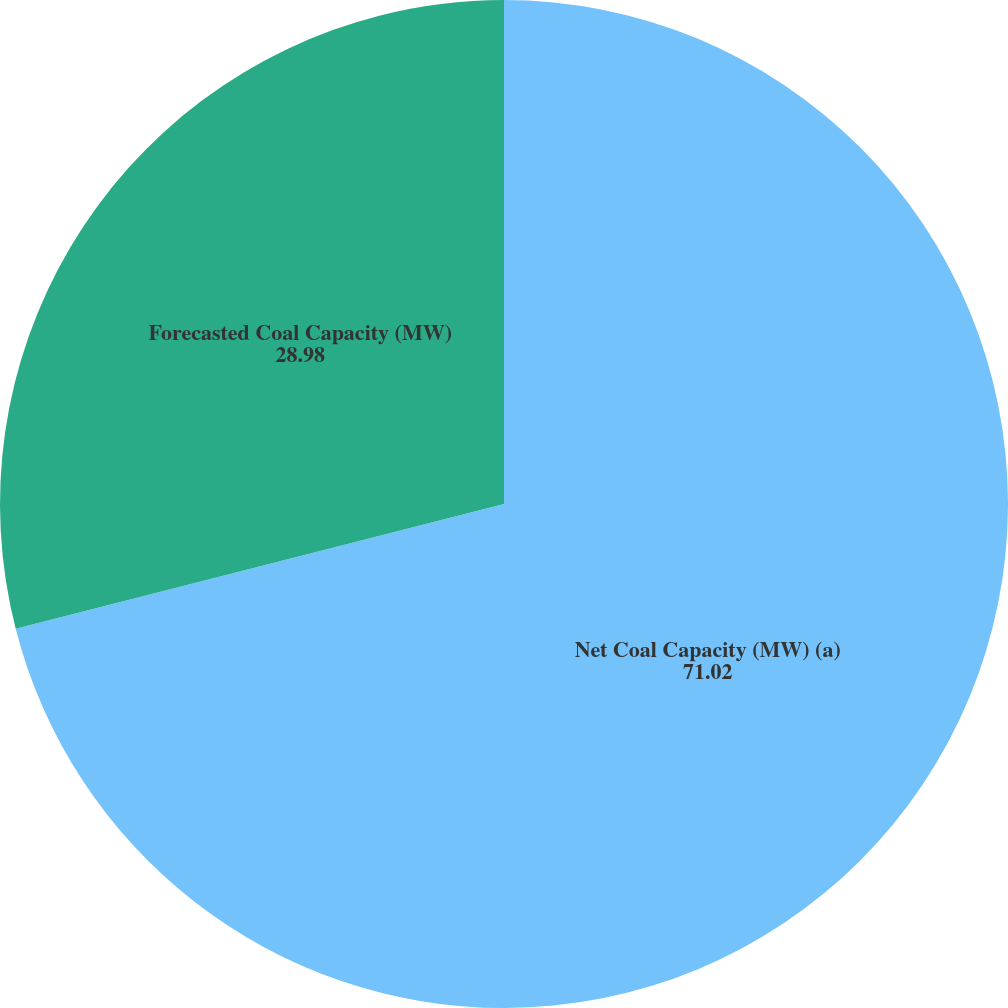Convert chart. <chart><loc_0><loc_0><loc_500><loc_500><pie_chart><fcel>Net Coal Capacity (MW) (a)<fcel>Forecasted Coal Capacity (MW)<nl><fcel>71.02%<fcel>28.98%<nl></chart> 